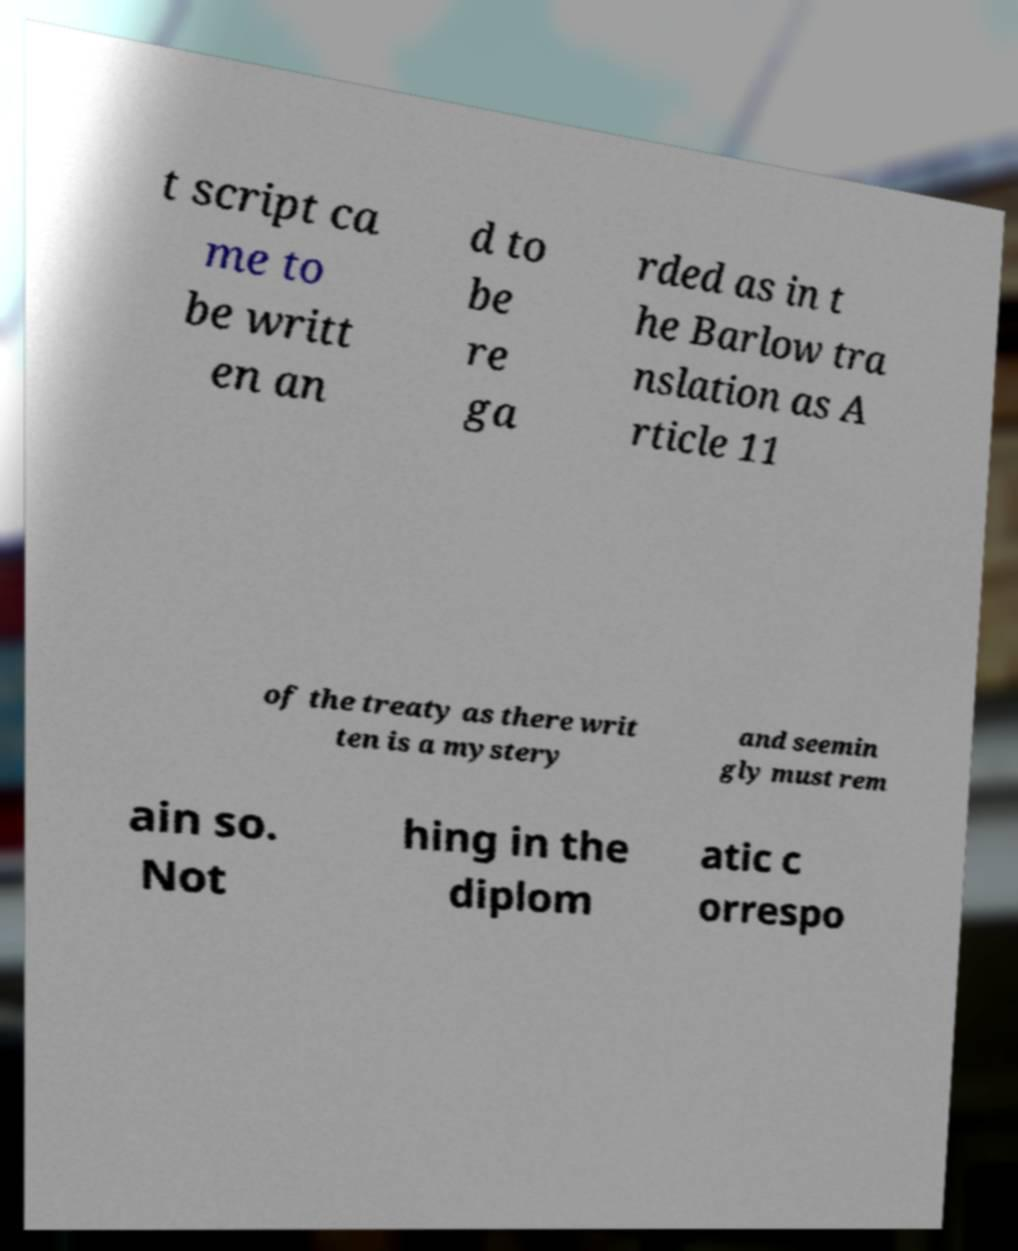What messages or text are displayed in this image? I need them in a readable, typed format. t script ca me to be writt en an d to be re ga rded as in t he Barlow tra nslation as A rticle 11 of the treaty as there writ ten is a mystery and seemin gly must rem ain so. Not hing in the diplom atic c orrespo 